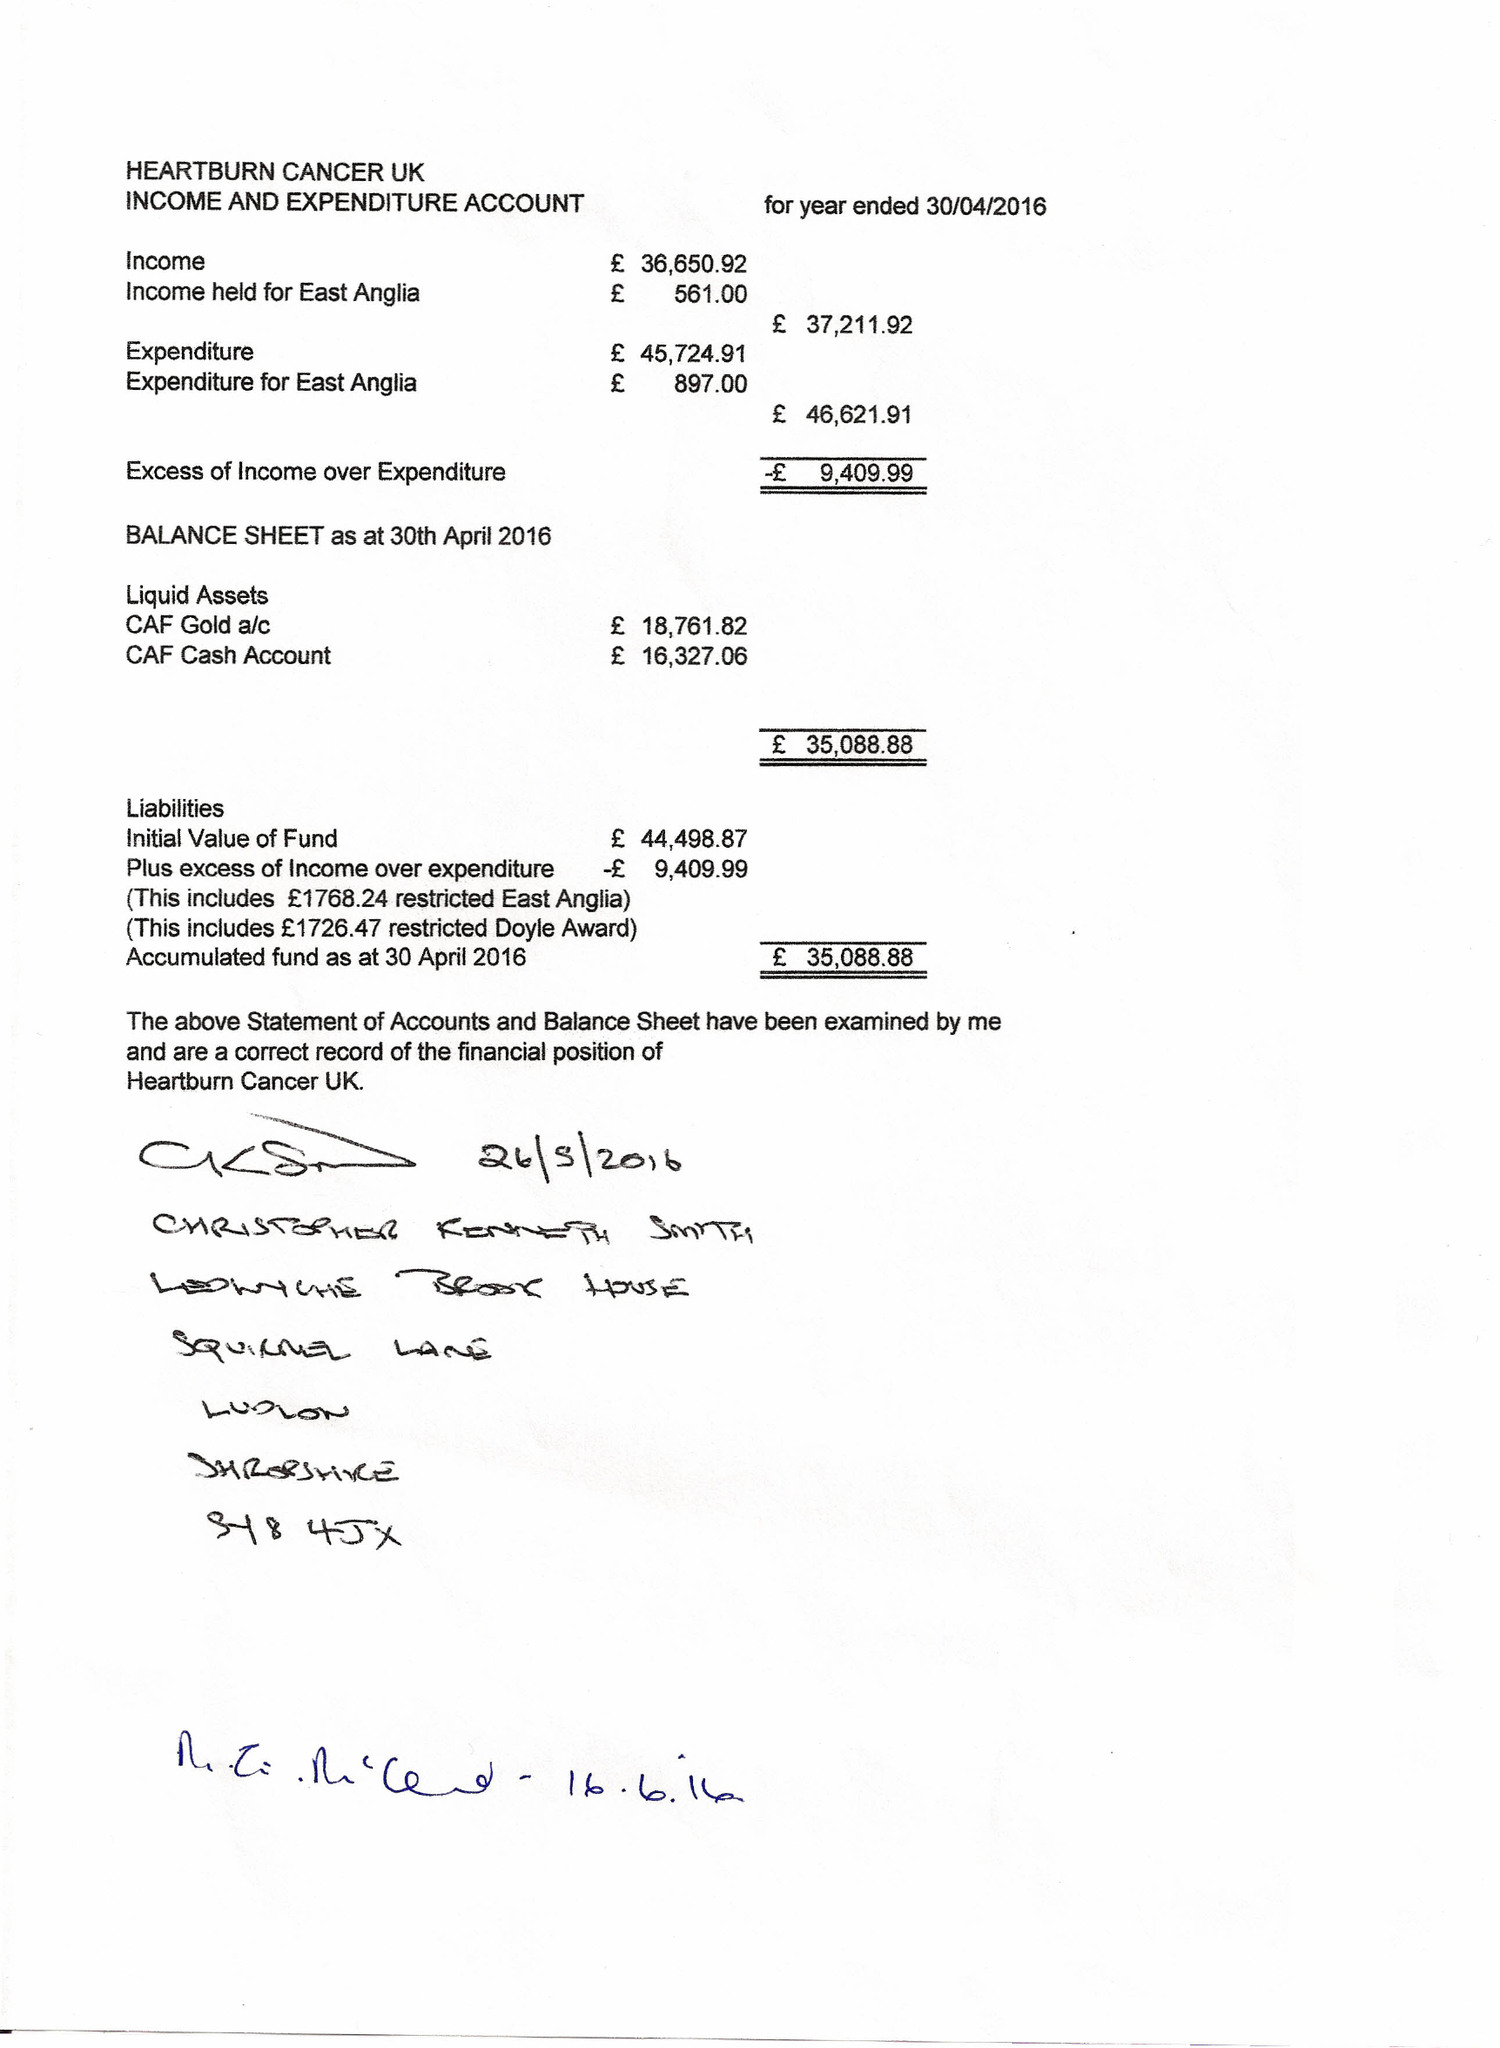What is the value for the income_annually_in_british_pounds?
Answer the question using a single word or phrase. 37212.00 